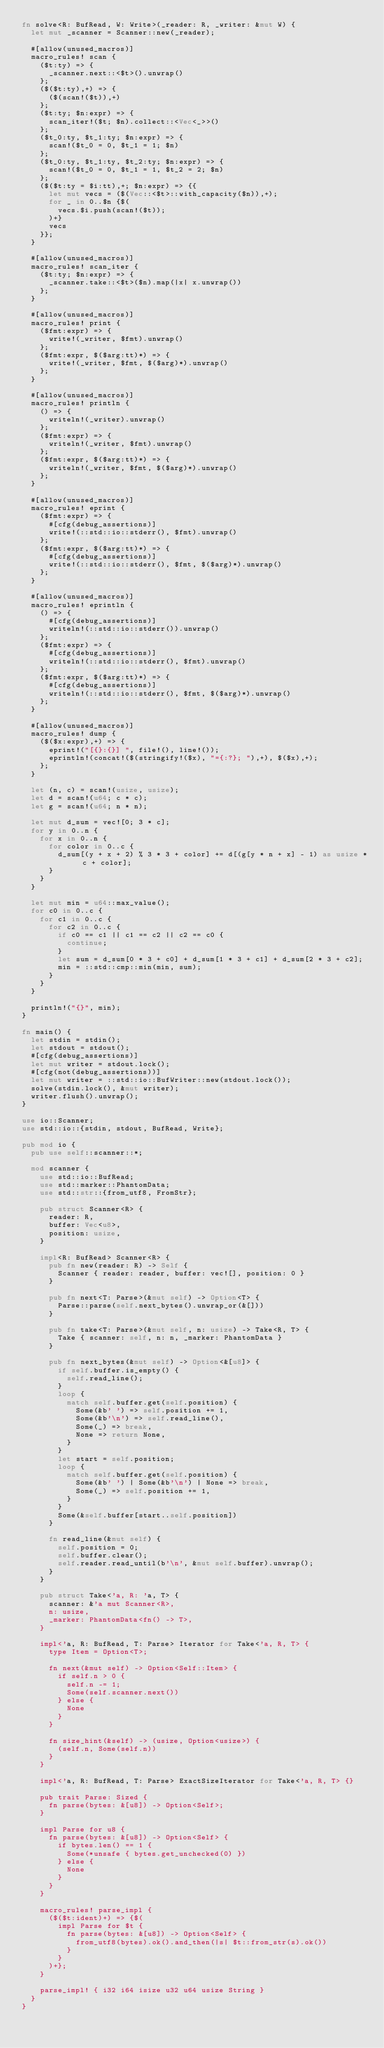<code> <loc_0><loc_0><loc_500><loc_500><_Rust_>fn solve<R: BufRead, W: Write>(_reader: R, _writer: &mut W) {
  let mut _scanner = Scanner::new(_reader);

  #[allow(unused_macros)]
  macro_rules! scan {
    ($t:ty) => {
      _scanner.next::<$t>().unwrap()
    };
    ($($t:ty),+) => {
      ($(scan!($t)),+)
    };
    ($t:ty; $n:expr) => {
      scan_iter!($t; $n).collect::<Vec<_>>()
    };
    ($t_0:ty, $t_1:ty; $n:expr) => {
      scan!($t_0 = 0, $t_1 = 1; $n)
    };
    ($t_0:ty, $t_1:ty, $t_2:ty; $n:expr) => {
      scan!($t_0 = 0, $t_1 = 1, $t_2 = 2; $n)
    };
    ($($t:ty = $i:tt),+; $n:expr) => {{
      let mut vecs = ($(Vec::<$t>::with_capacity($n)),+);
      for _ in 0..$n {$(
        vecs.$i.push(scan!($t));
      )+}
      vecs
    }};
  }

  #[allow(unused_macros)]
  macro_rules! scan_iter {
    ($t:ty; $n:expr) => {
      _scanner.take::<$t>($n).map(|x| x.unwrap())
    };
  }

  #[allow(unused_macros)]
  macro_rules! print {
    ($fmt:expr) => {
      write!(_writer, $fmt).unwrap()
    };
    ($fmt:expr, $($arg:tt)*) => {
      write!(_writer, $fmt, $($arg)*).unwrap()
    };
  }

  #[allow(unused_macros)]
  macro_rules! println {
    () => {
      writeln!(_writer).unwrap()
    };
    ($fmt:expr) => {
      writeln!(_writer, $fmt).unwrap()
    };
    ($fmt:expr, $($arg:tt)*) => {
      writeln!(_writer, $fmt, $($arg)*).unwrap()
    };
  }

  #[allow(unused_macros)]
  macro_rules! eprint {
    ($fmt:expr) => {
      #[cfg(debug_assertions)]
      write!(::std::io::stderr(), $fmt).unwrap()
    };
    ($fmt:expr, $($arg:tt)*) => {
      #[cfg(debug_assertions)]
      write!(::std::io::stderr(), $fmt, $($arg)*).unwrap()
    };
  }

  #[allow(unused_macros)]
  macro_rules! eprintln {
    () => {
      #[cfg(debug_assertions)]
      writeln!(::std::io::stderr()).unwrap()
    };
    ($fmt:expr) => {
      #[cfg(debug_assertions)]
      writeln!(::std::io::stderr(), $fmt).unwrap()
    };
    ($fmt:expr, $($arg:tt)*) => {
      #[cfg(debug_assertions)]
      writeln!(::std::io::stderr(), $fmt, $($arg)*).unwrap()
    };
  }

  #[allow(unused_macros)]
  macro_rules! dump {
    ($($x:expr),+) => {
      eprint!("[{}:{}] ", file!(), line!());
      eprintln!(concat!($(stringify!($x), "={:?}; "),+), $($x),+);
    };
  }

  let (n, c) = scan!(usize, usize);
  let d = scan!(u64; c * c);
  let g = scan!(u64; n * n);

  let mut d_sum = vec![0; 3 * c];
  for y in 0..n {
    for x in 0..n {
      for color in 0..c {
        d_sum[(y + x + 2) % 3 * 3 + color] += d[(g[y * n + x] - 1) as usize * c + color];
      }
    }
  }

  let mut min = u64::max_value();
  for c0 in 0..c {
    for c1 in 0..c {
      for c2 in 0..c {
        if c0 == c1 || c1 == c2 || c2 == c0 {
          continue;
        }
        let sum = d_sum[0 * 3 + c0] + d_sum[1 * 3 + c1] + d_sum[2 * 3 + c2];
        min = ::std::cmp::min(min, sum);
      }
    }
  }

  println!("{}", min);
}

fn main() {
  let stdin = stdin();
  let stdout = stdout();
  #[cfg(debug_assertions)]
  let mut writer = stdout.lock();
  #[cfg(not(debug_assertions))]
  let mut writer = ::std::io::BufWriter::new(stdout.lock());
  solve(stdin.lock(), &mut writer);
  writer.flush().unwrap();
}

use io::Scanner;
use std::io::{stdin, stdout, BufRead, Write};

pub mod io {
  pub use self::scanner::*;

  mod scanner {
    use std::io::BufRead;
    use std::marker::PhantomData;
    use std::str::{from_utf8, FromStr};

    pub struct Scanner<R> {
      reader: R,
      buffer: Vec<u8>,
      position: usize,
    }

    impl<R: BufRead> Scanner<R> {
      pub fn new(reader: R) -> Self {
        Scanner { reader: reader, buffer: vec![], position: 0 }
      }

      pub fn next<T: Parse>(&mut self) -> Option<T> {
        Parse::parse(self.next_bytes().unwrap_or(&[]))
      }

      pub fn take<T: Parse>(&mut self, n: usize) -> Take<R, T> {
        Take { scanner: self, n: n, _marker: PhantomData }
      }

      pub fn next_bytes(&mut self) -> Option<&[u8]> {
        if self.buffer.is_empty() {
          self.read_line();
        }
        loop {
          match self.buffer.get(self.position) {
            Some(&b' ') => self.position += 1,
            Some(&b'\n') => self.read_line(),
            Some(_) => break,
            None => return None,
          }
        }
        let start = self.position;
        loop {
          match self.buffer.get(self.position) {
            Some(&b' ') | Some(&b'\n') | None => break,
            Some(_) => self.position += 1,
          }
        }
        Some(&self.buffer[start..self.position])
      }

      fn read_line(&mut self) {
        self.position = 0;
        self.buffer.clear();
        self.reader.read_until(b'\n', &mut self.buffer).unwrap();
      }
    }

    pub struct Take<'a, R: 'a, T> {
      scanner: &'a mut Scanner<R>,
      n: usize,
      _marker: PhantomData<fn() -> T>,
    }

    impl<'a, R: BufRead, T: Parse> Iterator for Take<'a, R, T> {
      type Item = Option<T>;

      fn next(&mut self) -> Option<Self::Item> {
        if self.n > 0 {
          self.n -= 1;
          Some(self.scanner.next())
        } else {
          None
        }
      }

      fn size_hint(&self) -> (usize, Option<usize>) {
        (self.n, Some(self.n))
      }
    }

    impl<'a, R: BufRead, T: Parse> ExactSizeIterator for Take<'a, R, T> {}

    pub trait Parse: Sized {
      fn parse(bytes: &[u8]) -> Option<Self>;
    }

    impl Parse for u8 {
      fn parse(bytes: &[u8]) -> Option<Self> {
        if bytes.len() == 1 {
          Some(*unsafe { bytes.get_unchecked(0) })
        } else {
          None
        }
      }
    }

    macro_rules! parse_impl {
      ($($t:ident)+) => {$(
        impl Parse for $t {
          fn parse(bytes: &[u8]) -> Option<Self> {
            from_utf8(bytes).ok().and_then(|s| $t::from_str(s).ok())
          }
        }
      )+};
    }

    parse_impl! { i32 i64 isize u32 u64 usize String }
  }
}
</code> 